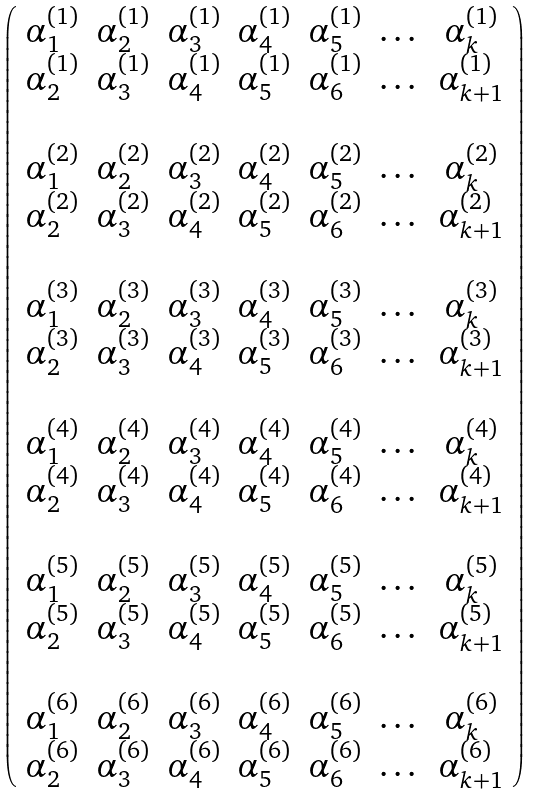<formula> <loc_0><loc_0><loc_500><loc_500>\left ( \begin{array} { c c c c c c c } \alpha _ { 1 } ^ { ( 1 ) } & \alpha _ { 2 } ^ { ( 1 ) } & \alpha _ { 3 } ^ { ( 1 ) } & \alpha _ { 4 } ^ { ( 1 ) } & \alpha _ { 5 } ^ { ( 1 ) } & \dots & \alpha _ { k } ^ { ( 1 ) } \\ \alpha _ { 2 } ^ { ( 1 ) } & \alpha _ { 3 } ^ { ( 1 ) } & \alpha _ { 4 } ^ { ( 1 ) } & \alpha _ { 5 } ^ { ( 1 ) } & \alpha _ { 6 } ^ { ( 1 ) } & \dots & \alpha _ { k + 1 } ^ { ( 1 ) } \\ \\ \alpha _ { 1 } ^ { ( 2 ) } & \alpha _ { 2 } ^ { ( 2 ) } & \alpha _ { 3 } ^ { ( 2 ) } & \alpha _ { 4 } ^ { ( 2 ) } & \alpha _ { 5 } ^ { ( 2 ) } & \dots & \alpha _ { k } ^ { ( 2 ) } \\ \alpha _ { 2 } ^ { ( 2 ) } & \alpha _ { 3 } ^ { ( 2 ) } & \alpha _ { 4 } ^ { ( 2 ) } & \alpha _ { 5 } ^ { ( 2 ) } & \alpha _ { 6 } ^ { ( 2 ) } & \dots & \alpha _ { k + 1 } ^ { ( 2 ) } \\ \\ \alpha _ { 1 } ^ { ( 3 ) } & \alpha _ { 2 } ^ { ( 3 ) } & \alpha _ { 3 } ^ { ( 3 ) } & \alpha _ { 4 } ^ { ( 3 ) } & \alpha _ { 5 } ^ { ( 3 ) } & \dots & \alpha _ { k } ^ { ( 3 ) } \\ \alpha _ { 2 } ^ { ( 3 ) } & \alpha _ { 3 } ^ { ( 3 ) } & \alpha _ { 4 } ^ { ( 3 ) } & \alpha _ { 5 } ^ { ( 3 ) } & \alpha _ { 6 } ^ { ( 3 ) } & \dots & \alpha _ { k + 1 } ^ { ( 3 ) } \\ \\ \alpha _ { 1 } ^ { ( 4 ) } & \alpha _ { 2 } ^ { ( 4 ) } & \alpha _ { 3 } ^ { ( 4 ) } & \alpha _ { 4 } ^ { ( 4 ) } & \alpha _ { 5 } ^ { ( 4 ) } & \dots & \alpha _ { k } ^ { ( 4 ) } \\ \alpha _ { 2 } ^ { ( 4 ) } & \alpha _ { 3 } ^ { ( 4 ) } & \alpha _ { 4 } ^ { ( 4 ) } & \alpha _ { 5 } ^ { ( 4 ) } & \alpha _ { 6 } ^ { ( 4 ) } & \dots & \alpha _ { k + 1 } ^ { ( 4 ) } \\ \\ \alpha _ { 1 } ^ { ( 5 ) } & \alpha _ { 2 } ^ { ( 5 ) } & \alpha _ { 3 } ^ { ( 5 ) } & \alpha _ { 4 } ^ { ( 5 ) } & \alpha _ { 5 } ^ { ( 5 ) } & \dots & \alpha _ { k } ^ { ( 5 ) } \\ \alpha _ { 2 } ^ { ( 5 ) } & \alpha _ { 3 } ^ { ( 5 ) } & \alpha _ { 4 } ^ { ( 5 ) } & \alpha _ { 5 } ^ { ( 5 ) } & \alpha _ { 6 } ^ { ( 5 ) } & \dots & \alpha _ { k + 1 } ^ { ( 5 ) } \\ \\ \alpha _ { 1 } ^ { ( 6 ) } & \alpha _ { 2 } ^ { ( 6 ) } & \alpha _ { 3 } ^ { ( 6 ) } & \alpha _ { 4 } ^ { ( 6 ) } & \alpha _ { 5 } ^ { ( 6 ) } & \dots & \alpha _ { k } ^ { ( 6 ) } \\ \alpha _ { 2 } ^ { ( 6 ) } & \alpha _ { 3 } ^ { ( 6 ) } & \alpha _ { 4 } ^ { ( 6 ) } & \alpha _ { 5 } ^ { ( 6 ) } & \alpha _ { 6 } ^ { ( 6 ) } & \dots & \alpha _ { k + 1 } ^ { ( 6 ) } \\ \end{array} \right )</formula> 